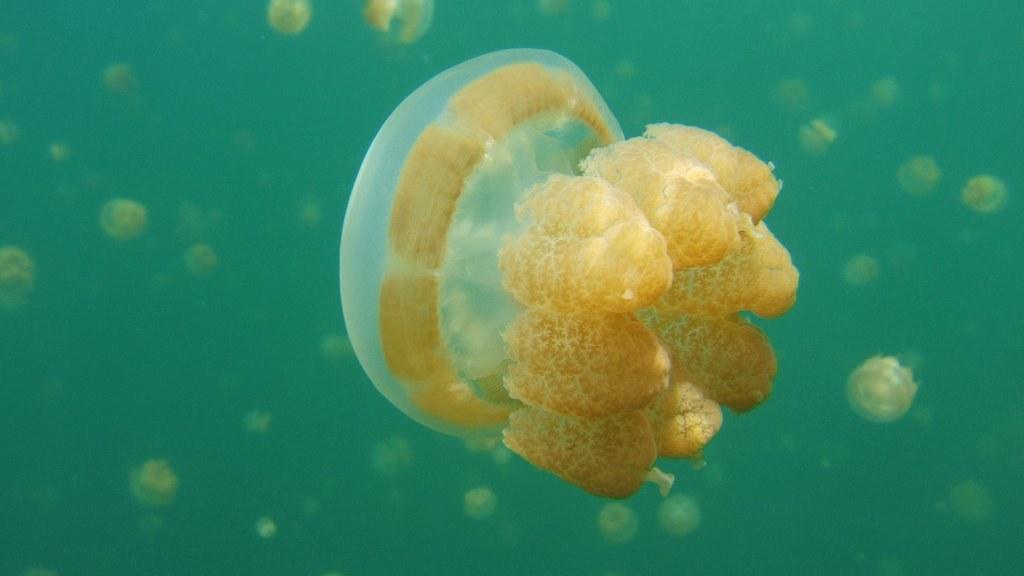Could you give a brief overview of what you see in this image? In this image we can see jellyfishes in the water. 